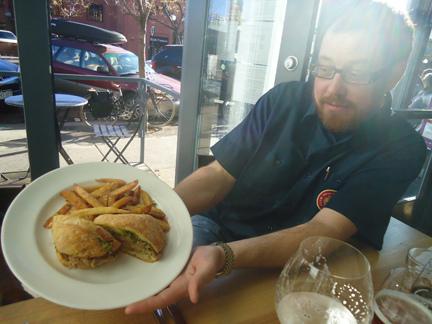Where is the red car parked?
Keep it brief. Outside. What is being drunk in this photo?
Answer briefly. Beer. What is he holding?
Keep it brief. Plate. 